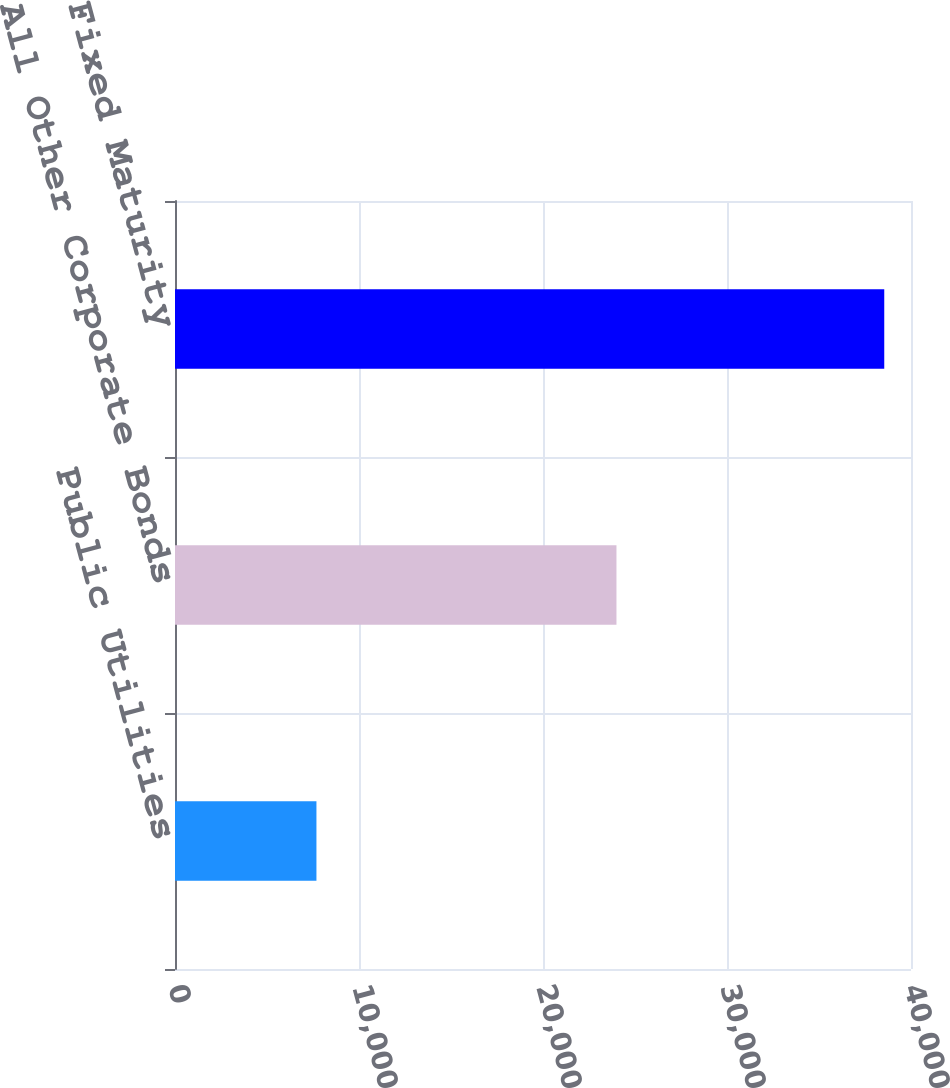<chart> <loc_0><loc_0><loc_500><loc_500><bar_chart><fcel>Public Utilities<fcel>All Other Corporate Bonds<fcel>Total Fixed Maturity<nl><fcel>7687.2<fcel>23992.8<fcel>38546.4<nl></chart> 